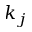<formula> <loc_0><loc_0><loc_500><loc_500>k _ { j }</formula> 